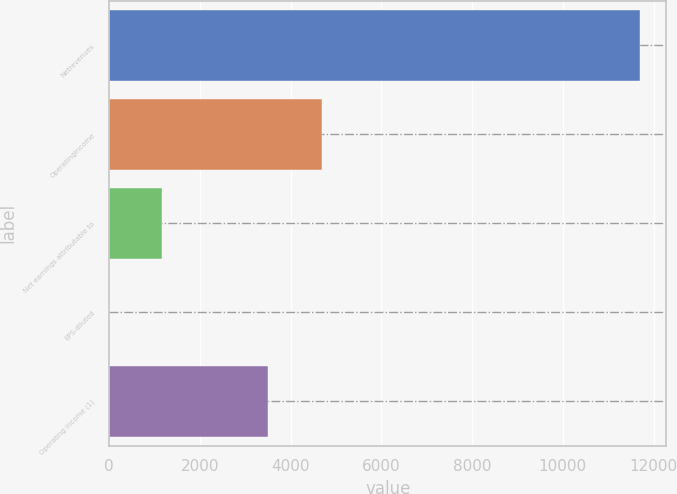<chart> <loc_0><loc_0><loc_500><loc_500><bar_chart><fcel>Netrevenues<fcel>Operatingincome<fcel>Net earnings attributable to<fcel>EPS-diluted<fcel>Operating income (1)<nl><fcel>11700.4<fcel>4681.14<fcel>1171.5<fcel>1.62<fcel>3511.26<nl></chart> 